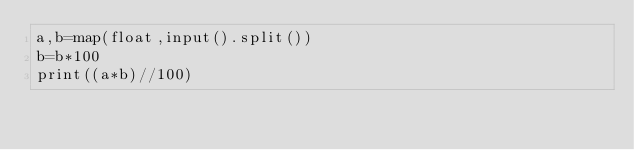Convert code to text. <code><loc_0><loc_0><loc_500><loc_500><_Python_>a,b=map(float,input().split())
b=b*100
print((a*b)//100)
    
</code> 